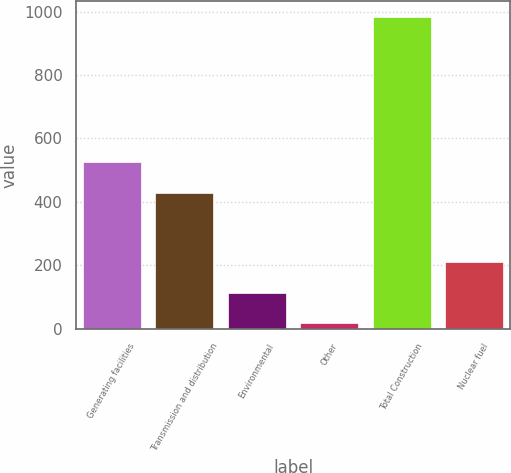Convert chart to OTSL. <chart><loc_0><loc_0><loc_500><loc_500><bar_chart><fcel>Generating facilities<fcel>Transmission and distribution<fcel>Environmental<fcel>Other<fcel>Total Construction<fcel>Nuclear fuel<nl><fcel>524.7<fcel>428<fcel>113.7<fcel>17<fcel>984<fcel>210.4<nl></chart> 